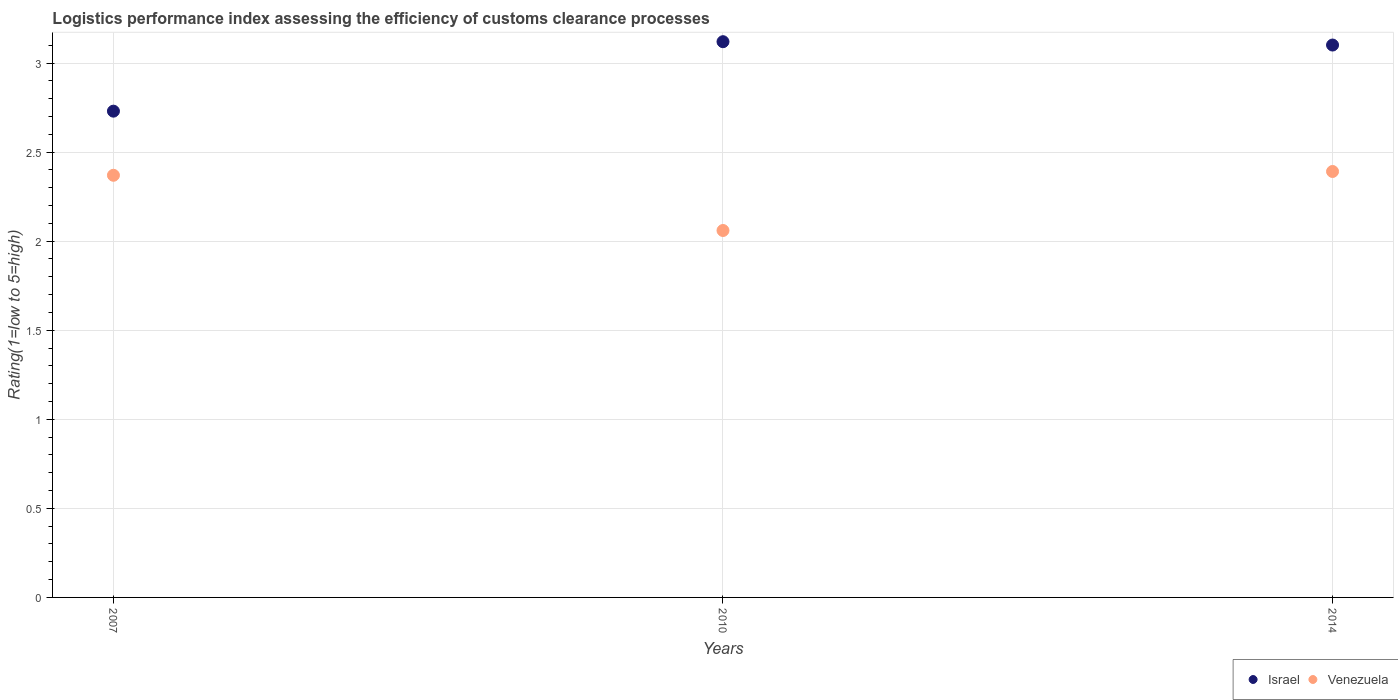Is the number of dotlines equal to the number of legend labels?
Give a very brief answer. Yes. What is the Logistic performance index in Israel in 2014?
Provide a succinct answer. 3.1. Across all years, what is the maximum Logistic performance index in Israel?
Your answer should be compact. 3.12. Across all years, what is the minimum Logistic performance index in Venezuela?
Your answer should be compact. 2.06. In which year was the Logistic performance index in Israel maximum?
Ensure brevity in your answer.  2010. What is the total Logistic performance index in Israel in the graph?
Provide a short and direct response. 8.95. What is the difference between the Logistic performance index in Israel in 2007 and that in 2014?
Your answer should be very brief. -0.37. What is the difference between the Logistic performance index in Venezuela in 2014 and the Logistic performance index in Israel in 2007?
Provide a succinct answer. -0.34. What is the average Logistic performance index in Israel per year?
Ensure brevity in your answer.  2.98. In the year 2010, what is the difference between the Logistic performance index in Israel and Logistic performance index in Venezuela?
Your answer should be very brief. 1.06. In how many years, is the Logistic performance index in Venezuela greater than 1.2?
Offer a very short reply. 3. What is the ratio of the Logistic performance index in Venezuela in 2007 to that in 2014?
Your answer should be compact. 0.99. Is the Logistic performance index in Israel in 2007 less than that in 2010?
Keep it short and to the point. Yes. Is the difference between the Logistic performance index in Israel in 2007 and 2010 greater than the difference between the Logistic performance index in Venezuela in 2007 and 2010?
Offer a very short reply. No. What is the difference between the highest and the second highest Logistic performance index in Israel?
Make the answer very short. 0.02. What is the difference between the highest and the lowest Logistic performance index in Israel?
Your answer should be compact. 0.39. In how many years, is the Logistic performance index in Israel greater than the average Logistic performance index in Israel taken over all years?
Your response must be concise. 2. Does the Logistic performance index in Israel monotonically increase over the years?
Your answer should be very brief. No. Is the Logistic performance index in Venezuela strictly less than the Logistic performance index in Israel over the years?
Give a very brief answer. Yes. How many dotlines are there?
Your answer should be very brief. 2. How many years are there in the graph?
Provide a succinct answer. 3. Does the graph contain any zero values?
Your answer should be compact. No. Does the graph contain grids?
Give a very brief answer. Yes. Where does the legend appear in the graph?
Offer a terse response. Bottom right. How are the legend labels stacked?
Offer a terse response. Horizontal. What is the title of the graph?
Provide a succinct answer. Logistics performance index assessing the efficiency of customs clearance processes. What is the label or title of the Y-axis?
Your answer should be compact. Rating(1=low to 5=high). What is the Rating(1=low to 5=high) of Israel in 2007?
Offer a very short reply. 2.73. What is the Rating(1=low to 5=high) in Venezuela in 2007?
Provide a short and direct response. 2.37. What is the Rating(1=low to 5=high) of Israel in 2010?
Make the answer very short. 3.12. What is the Rating(1=low to 5=high) in Venezuela in 2010?
Your answer should be very brief. 2.06. What is the Rating(1=low to 5=high) in Israel in 2014?
Ensure brevity in your answer.  3.1. What is the Rating(1=low to 5=high) of Venezuela in 2014?
Your answer should be very brief. 2.39. Across all years, what is the maximum Rating(1=low to 5=high) of Israel?
Provide a short and direct response. 3.12. Across all years, what is the maximum Rating(1=low to 5=high) of Venezuela?
Offer a terse response. 2.39. Across all years, what is the minimum Rating(1=low to 5=high) in Israel?
Offer a very short reply. 2.73. Across all years, what is the minimum Rating(1=low to 5=high) of Venezuela?
Keep it short and to the point. 2.06. What is the total Rating(1=low to 5=high) in Israel in the graph?
Your answer should be very brief. 8.95. What is the total Rating(1=low to 5=high) in Venezuela in the graph?
Make the answer very short. 6.82. What is the difference between the Rating(1=low to 5=high) in Israel in 2007 and that in 2010?
Offer a very short reply. -0.39. What is the difference between the Rating(1=low to 5=high) in Venezuela in 2007 and that in 2010?
Ensure brevity in your answer.  0.31. What is the difference between the Rating(1=low to 5=high) of Israel in 2007 and that in 2014?
Provide a short and direct response. -0.37. What is the difference between the Rating(1=low to 5=high) of Venezuela in 2007 and that in 2014?
Ensure brevity in your answer.  -0.02. What is the difference between the Rating(1=low to 5=high) of Israel in 2010 and that in 2014?
Keep it short and to the point. 0.02. What is the difference between the Rating(1=low to 5=high) of Venezuela in 2010 and that in 2014?
Keep it short and to the point. -0.33. What is the difference between the Rating(1=low to 5=high) of Israel in 2007 and the Rating(1=low to 5=high) of Venezuela in 2010?
Your response must be concise. 0.67. What is the difference between the Rating(1=low to 5=high) in Israel in 2007 and the Rating(1=low to 5=high) in Venezuela in 2014?
Your answer should be compact. 0.34. What is the difference between the Rating(1=low to 5=high) of Israel in 2010 and the Rating(1=low to 5=high) of Venezuela in 2014?
Offer a terse response. 0.73. What is the average Rating(1=low to 5=high) of Israel per year?
Provide a short and direct response. 2.98. What is the average Rating(1=low to 5=high) in Venezuela per year?
Provide a short and direct response. 2.27. In the year 2007, what is the difference between the Rating(1=low to 5=high) of Israel and Rating(1=low to 5=high) of Venezuela?
Keep it short and to the point. 0.36. In the year 2010, what is the difference between the Rating(1=low to 5=high) of Israel and Rating(1=low to 5=high) of Venezuela?
Your response must be concise. 1.06. In the year 2014, what is the difference between the Rating(1=low to 5=high) of Israel and Rating(1=low to 5=high) of Venezuela?
Provide a succinct answer. 0.71. What is the ratio of the Rating(1=low to 5=high) of Israel in 2007 to that in 2010?
Your answer should be very brief. 0.88. What is the ratio of the Rating(1=low to 5=high) of Venezuela in 2007 to that in 2010?
Provide a succinct answer. 1.15. What is the ratio of the Rating(1=low to 5=high) of Israel in 2007 to that in 2014?
Your answer should be compact. 0.88. What is the ratio of the Rating(1=low to 5=high) of Venezuela in 2007 to that in 2014?
Keep it short and to the point. 0.99. What is the ratio of the Rating(1=low to 5=high) of Venezuela in 2010 to that in 2014?
Offer a terse response. 0.86. What is the difference between the highest and the second highest Rating(1=low to 5=high) in Israel?
Provide a succinct answer. 0.02. What is the difference between the highest and the second highest Rating(1=low to 5=high) of Venezuela?
Make the answer very short. 0.02. What is the difference between the highest and the lowest Rating(1=low to 5=high) in Israel?
Keep it short and to the point. 0.39. What is the difference between the highest and the lowest Rating(1=low to 5=high) in Venezuela?
Provide a succinct answer. 0.33. 